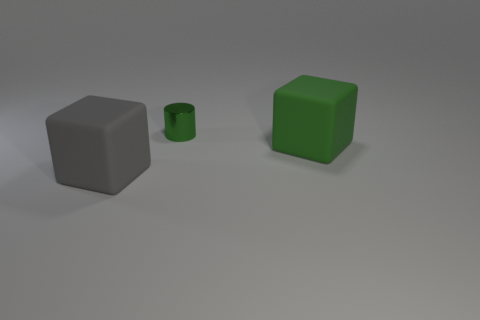What number of things are tiny blue rubber objects or big matte blocks that are right of the small object?
Make the answer very short. 1. There is a matte thing left of the green cube; does it have the same size as the large green rubber block?
Offer a terse response. Yes. How many other things are the same size as the green rubber object?
Your answer should be compact. 1. What color is the tiny thing?
Offer a very short reply. Green. There is a cube in front of the big green cube; what is it made of?
Make the answer very short. Rubber. Are there the same number of small green cylinders behind the tiny object and yellow things?
Provide a succinct answer. Yes. Does the metallic object have the same shape as the green matte thing?
Offer a very short reply. No. Is there any other thing of the same color as the tiny object?
Your answer should be very brief. Yes. What is the shape of the thing that is both on the right side of the big gray thing and to the left of the big green rubber cube?
Your response must be concise. Cylinder. Is the number of shiny cylinders on the right side of the small metal cylinder the same as the number of large objects that are on the left side of the big gray rubber thing?
Your answer should be compact. Yes. 